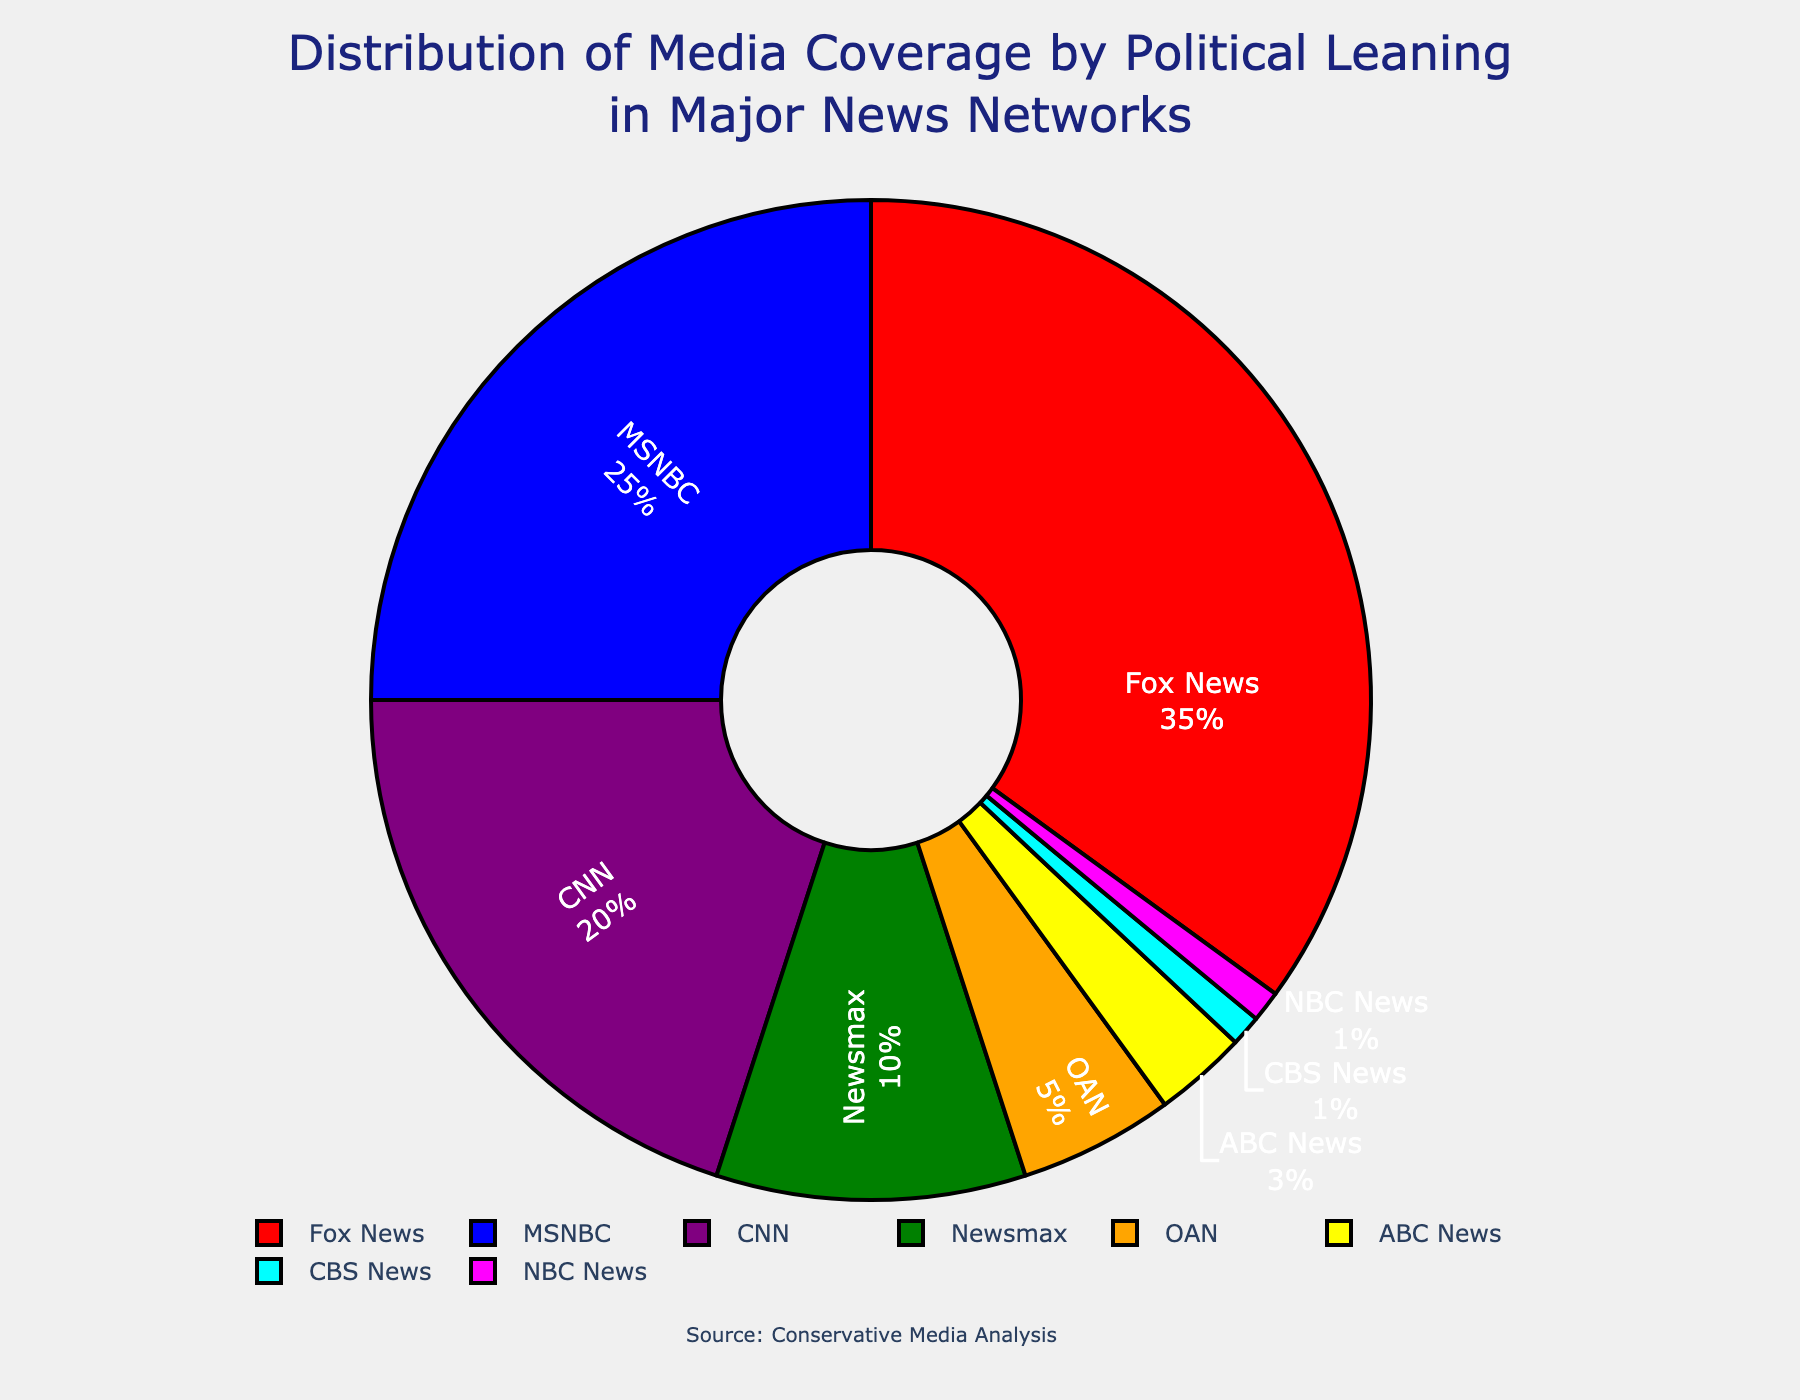What's the combined coverage percentage of Fox News and CNN? First, identify the coverage percentage of Fox News (35%) and CNN (20%) from the pie chart. Sum them together: 35% + 20% = 55%.
Answer: 55% Which network has the smallest coverage percentage? Observe the pie chart and identify the network with the smallest portion, which is NBC News and CBS News, each having 1%.
Answer: NBC News and CBS News Which network covers more, OAN or ABC News? Compare the portions for OAN (5%) and ABC News (3%) in the pie chart. Since 5% is greater than 3%, OAN covers more.
Answer: OAN What is the color representing MSNBC in the pie chart? Look for the color segment associated with MSNBC, which is colored in blue.
Answer: Blue How much more does Fox News cover compared to MSNBC? Determine the coverage percentages for Fox News (35%) and MSNBC (25%). Subtract MSNBC's percentage from Fox News's: 35% - 25% = 10%.
Answer: 10% What is the total coverage percentage of Newsmax and OAN combined? Identify the coverage percentages for Newsmax (10%) and OAN (5%) from the pie chart. Sum them together: 10% + 5% = 15%.
Answer: 15% Is CNN's coverage percentage greater than Newsmax and OAN combined? Find CNN's coverage percentage (20%) and the combined percentage of Newsmax (10%) and OAN (5%): 10% + 5% = 15%. Compare 20% and 15%. Since 20% > 15%, CNN's coverage is greater.
Answer: Yes What fraction of the total coverage does ABC News represent? Observe ABC News's coverage (3%) in the pie chart. Convert the percentage to a fraction: 3% of 100% is 3/100, which simplifies to 3/100.
Answer: 3/100 If the total coverage percentage is normalized to 100, what percentage does each news network have if the figure only included Fox News, MSNBC, and CNN? First, find the combined total for Fox News (35%), MSNBC (25%), and CNN (20%), which is 35% + 25% + 20% = 80%. Each network's new coverage percentage is calculated as follows: Fox News: (35/80) * 100 = 43.75%, MSNBC: (25/80) * 100 = 31.25%, CNN: (20/80) * 100 = 25%.
Answer: Fox News: 43.75%, MSNBC: 31.25%, CNN: 25% How many networks have a coverage percentage less than 10%? Identify the networks with coverage percentages below 10% from the pie chart: OAN (5%), ABC News (3%), CBS News (1%), and NBC News (1%). Count these networks, which totals to 4.
Answer: 4 